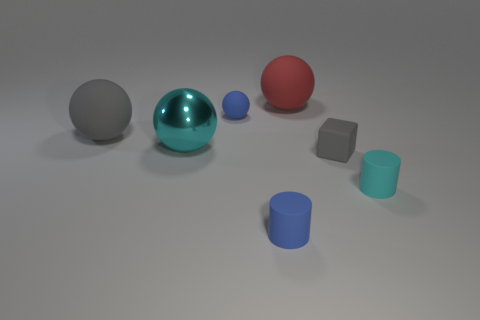Subtract all gray matte spheres. How many spheres are left? 3 Add 1 large shiny balls. How many objects exist? 8 Subtract all gray spheres. How many spheres are left? 3 Subtract all green balls. Subtract all yellow cubes. How many balls are left? 4 Subtract all tiny blue spheres. Subtract all gray objects. How many objects are left? 4 Add 1 cyan cylinders. How many cyan cylinders are left? 2 Add 6 tiny purple matte objects. How many tiny purple matte objects exist? 6 Subtract 1 blue cylinders. How many objects are left? 6 Subtract all spheres. How many objects are left? 3 